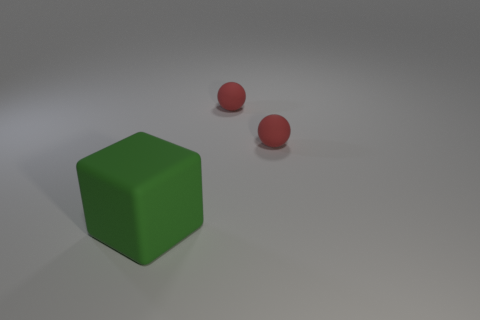What number of small red balls have the same material as the green object? 2 